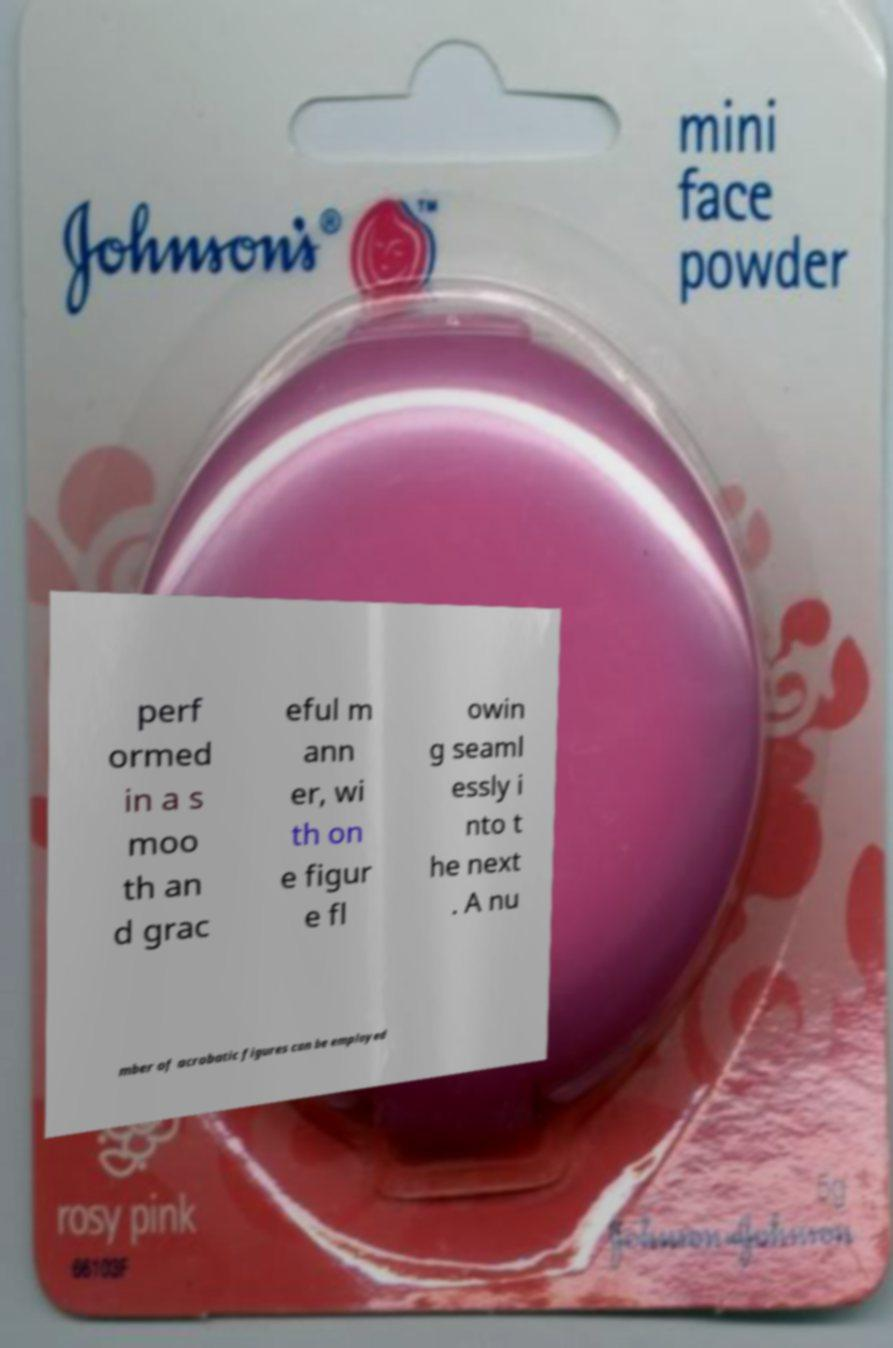I need the written content from this picture converted into text. Can you do that? perf ormed in a s moo th an d grac eful m ann er, wi th on e figur e fl owin g seaml essly i nto t he next . A nu mber of acrobatic figures can be employed 